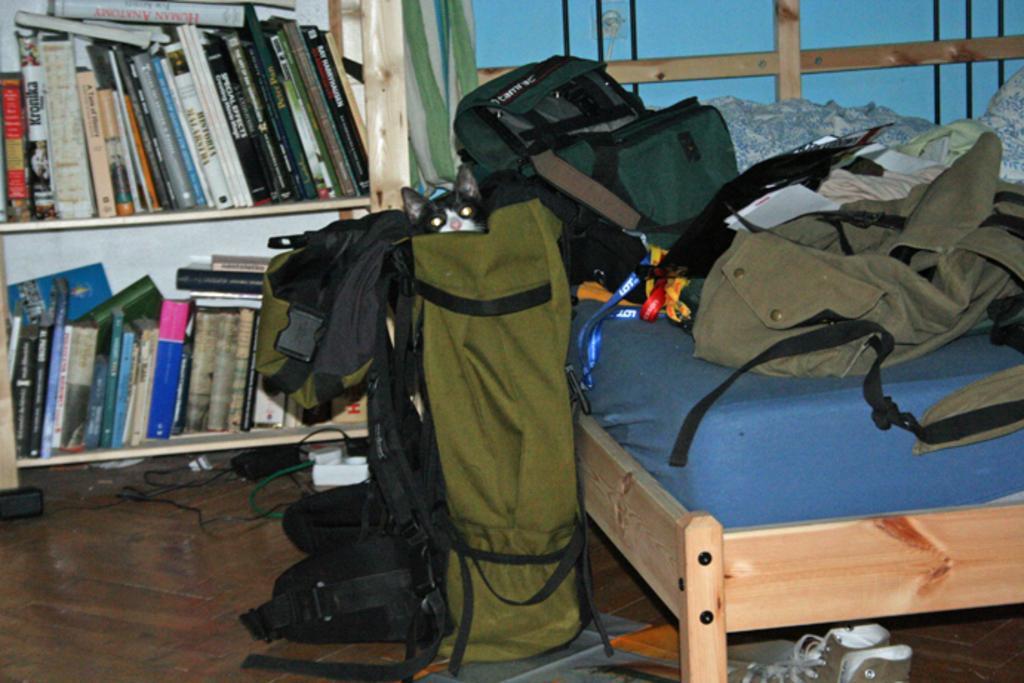How would you summarize this image in a sentence or two? This image is clicked in a room. There is a cot right side and their bookshelves left side. There books in bookshelves. There are bags on the bed. There are shoes under the bed in the bottom. There are wires under the bookshelves. 